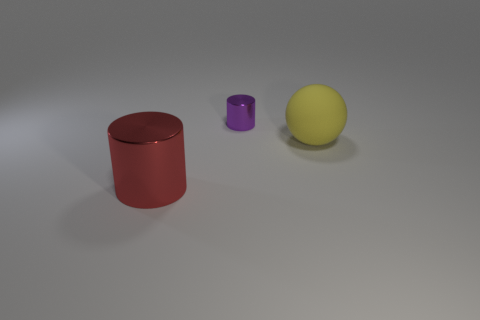Are there fewer rubber things that are in front of the large rubber sphere than big rubber spheres?
Offer a very short reply. Yes. Are there fewer metal things that are behind the big rubber thing than purple objects to the right of the small purple shiny cylinder?
Your response must be concise. No. What number of blocks are big yellow objects or big red shiny things?
Your answer should be compact. 0. Is the big thing that is on the left side of the large rubber sphere made of the same material as the cylinder that is behind the big ball?
Your answer should be very brief. Yes. What shape is the red object that is the same size as the yellow rubber thing?
Provide a short and direct response. Cylinder. What number of yellow objects are large balls or big metal objects?
Your answer should be compact. 1. Do the big object that is left of the purple shiny cylinder and the metallic object that is behind the large cylinder have the same shape?
Offer a terse response. Yes. What number of other objects are there of the same material as the big yellow thing?
Keep it short and to the point. 0. There is a big thing behind the shiny cylinder left of the tiny purple thing; are there any large red things in front of it?
Provide a succinct answer. Yes. Is the tiny purple thing made of the same material as the ball?
Provide a short and direct response. No. 